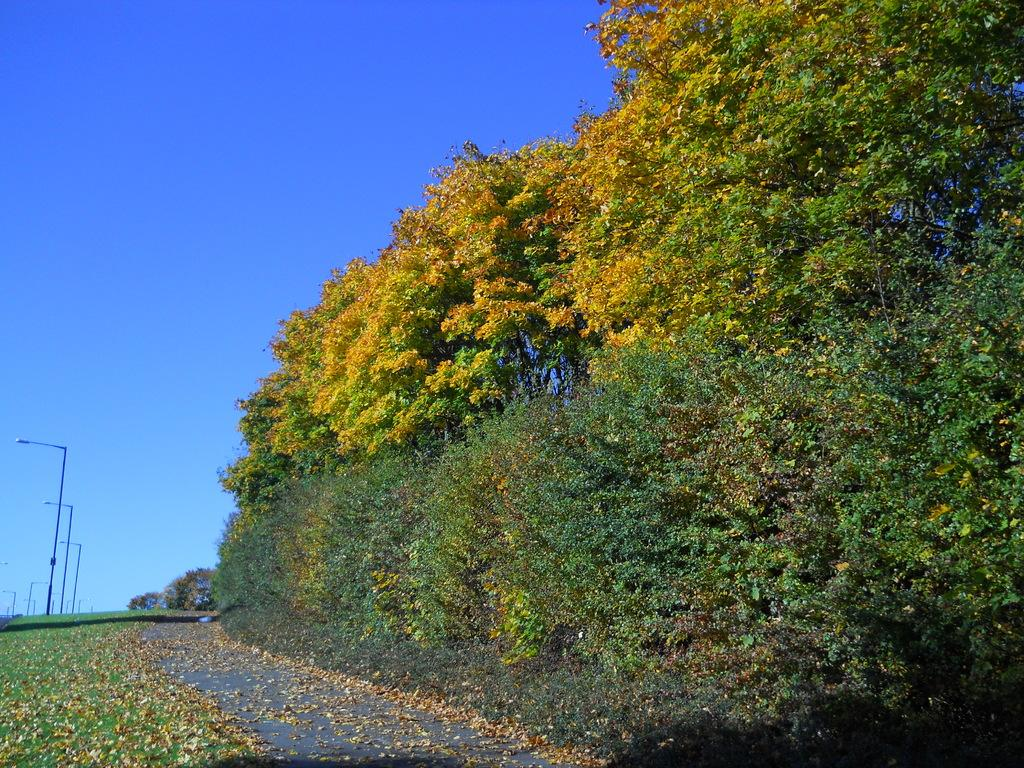What type of vegetation can be seen in the image? There are trees and plants in the image. What kind of path is present in the image? There is a walkway in the image. What type of ground cover is visible in the image? There is grass in the image. What structures are present in the image? There are poles in the image. What is visible in the background of the image? The sky is visible in the background of the image. Where is the cannon located in the image? There is no cannon present in the image. What type of bird is sitting on the pole in the image? There are no birds, including crows, present in the image. What tool is being used to clean the grass in the image? There is no rake or any other tool visible in the image. 